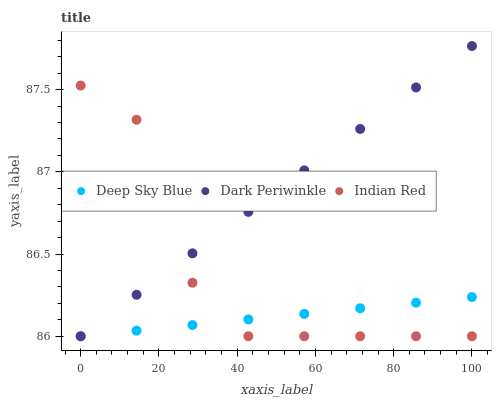Does Deep Sky Blue have the minimum area under the curve?
Answer yes or no. Yes. Does Dark Periwinkle have the maximum area under the curve?
Answer yes or no. Yes. Does Dark Periwinkle have the minimum area under the curve?
Answer yes or no. No. Does Deep Sky Blue have the maximum area under the curve?
Answer yes or no. No. Is Deep Sky Blue the smoothest?
Answer yes or no. Yes. Is Indian Red the roughest?
Answer yes or no. Yes. Is Dark Periwinkle the smoothest?
Answer yes or no. No. Is Dark Periwinkle the roughest?
Answer yes or no. No. Does Indian Red have the lowest value?
Answer yes or no. Yes. Does Dark Periwinkle have the highest value?
Answer yes or no. Yes. Does Deep Sky Blue have the highest value?
Answer yes or no. No. Does Deep Sky Blue intersect Dark Periwinkle?
Answer yes or no. Yes. Is Deep Sky Blue less than Dark Periwinkle?
Answer yes or no. No. Is Deep Sky Blue greater than Dark Periwinkle?
Answer yes or no. No. 